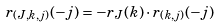<formula> <loc_0><loc_0><loc_500><loc_500>r _ { ( J , k , j ) } ( - j ) = - r _ { J } ( k ) \cdot r _ { ( k , j ) } ( - j )</formula> 